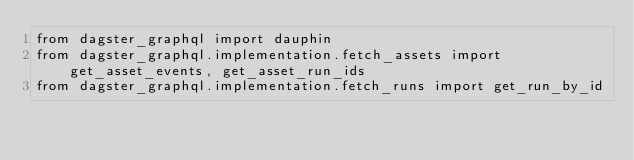<code> <loc_0><loc_0><loc_500><loc_500><_Python_>from dagster_graphql import dauphin
from dagster_graphql.implementation.fetch_assets import get_asset_events, get_asset_run_ids
from dagster_graphql.implementation.fetch_runs import get_run_by_id</code> 